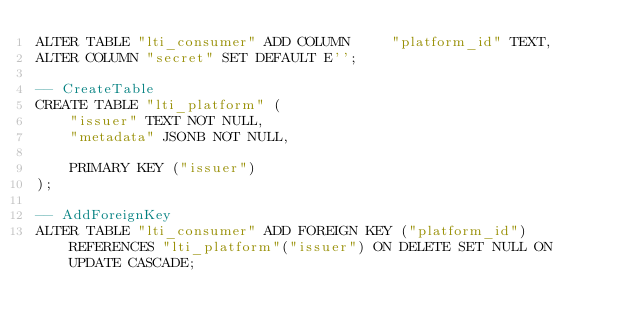<code> <loc_0><loc_0><loc_500><loc_500><_SQL_>ALTER TABLE "lti_consumer" ADD COLUMN     "platform_id" TEXT,
ALTER COLUMN "secret" SET DEFAULT E'';

-- CreateTable
CREATE TABLE "lti_platform" (
    "issuer" TEXT NOT NULL,
    "metadata" JSONB NOT NULL,

    PRIMARY KEY ("issuer")
);

-- AddForeignKey
ALTER TABLE "lti_consumer" ADD FOREIGN KEY ("platform_id") REFERENCES "lti_platform"("issuer") ON DELETE SET NULL ON UPDATE CASCADE;
</code> 